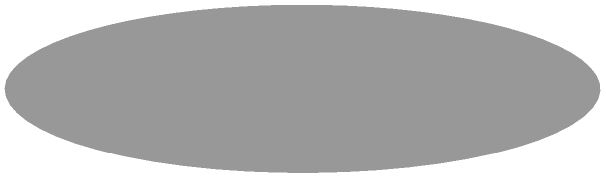As the winner of "Breakout Star of the Year" at the Diversity in Media Awards, you've received a unique trophy. The trophy consists of a circular base with a radius of 1 cm, a tapered body that narrows from the base to a height of 2 cm, and a circular top with a radius of 0.5 cm. What is the total surface area of this trophy in square centimeters? (Use $\pi = 3.14$ for calculations) Let's break this down step-by-step:

1) Surface area of the circular base:
   $A_{base} = \pi r^2 = 3.14 \times 1^2 = 3.14$ cm²

2) Surface area of the circular top:
   $A_{top} = \pi r^2 = 3.14 \times 0.5^2 = 0.785$ cm²

3) For the tapered side, we need to calculate the surface area of a truncated cone:
   The formula is $\pi(r_1 + r_2)\sqrt{h^2 + (r_1 - r_2)^2}$
   Where $r_1 = 1$ cm, $r_2 = 0.5$ cm, and $h = 2$ cm

   $A_{side} = 3.14(1 + 0.5)\sqrt{2^2 + (1 - 0.5)^2}$
              $= 4.71\sqrt{4 + 0.25}$
              $= 4.71\sqrt{4.25}$
              $= 4.71 \times 2.06$
              $= 9.7026$ cm²

4) Total surface area:
   $A_{total} = A_{base} + A_{top} + A_{side}$
               $= 3.14 + 0.785 + 9.7026$
               $= 13.6276$ cm²

Rounding to two decimal places: 13.63 cm²
Answer: 13.63 cm² 